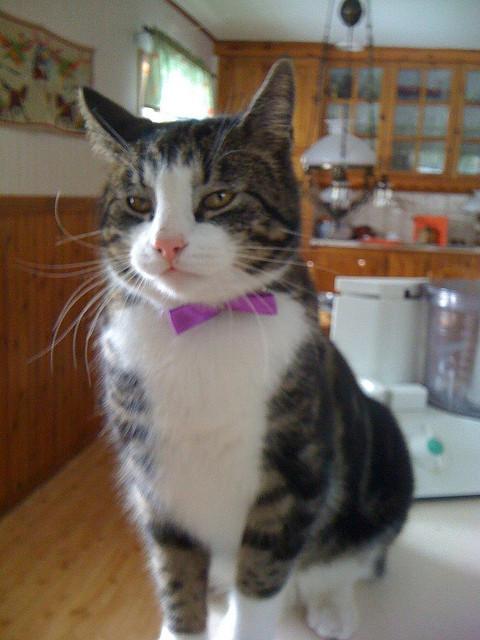What part of the house was this picture taken?
Keep it brief. Kitchen. Can the cat talk to you?
Short answer required. No. What other bigger animal resembles this cat?
Be succinct. Tiger. Is the cat mostly black?
Quick response, please. No. How many computers?
Write a very short answer. 0. What color is the cats bow?
Short answer required. Purple. How amused does this cat look at wearing a bowl on its head?
Concise answer only. Not amused. Is this cat's mouth open?
Give a very brief answer. No. What room is this?
Answer briefly. Kitchen. 